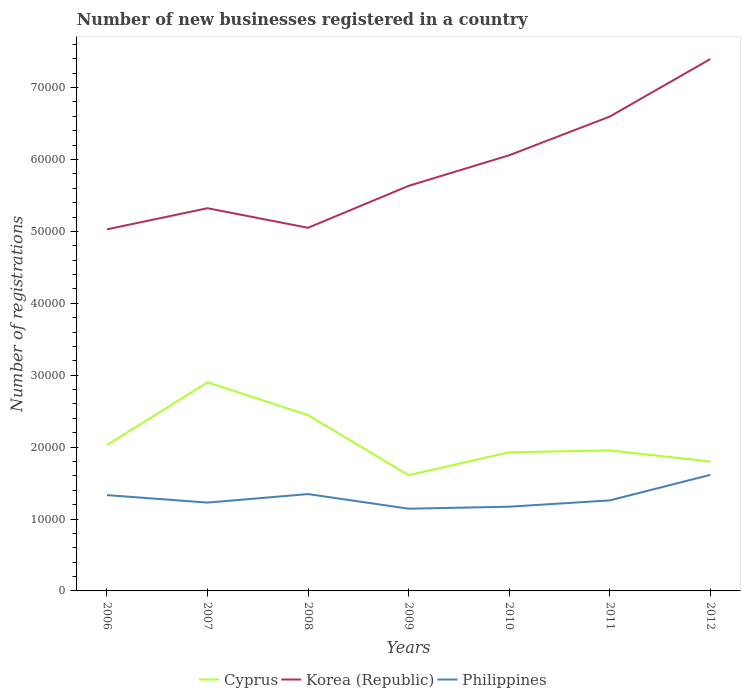Does the line corresponding to Philippines intersect with the line corresponding to Cyprus?
Keep it short and to the point. No. Is the number of lines equal to the number of legend labels?
Your answer should be compact. Yes. Across all years, what is the maximum number of new businesses registered in Korea (Republic)?
Your answer should be very brief. 5.03e+04. What is the total number of new businesses registered in Korea (Republic) in the graph?
Offer a terse response. -2.35e+04. What is the difference between the highest and the second highest number of new businesses registered in Korea (Republic)?
Offer a terse response. 2.37e+04. Is the number of new businesses registered in Korea (Republic) strictly greater than the number of new businesses registered in Cyprus over the years?
Provide a short and direct response. No. How many lines are there?
Offer a terse response. 3. How many legend labels are there?
Provide a succinct answer. 3. What is the title of the graph?
Your response must be concise. Number of new businesses registered in a country. Does "Gabon" appear as one of the legend labels in the graph?
Your answer should be very brief. No. What is the label or title of the X-axis?
Keep it short and to the point. Years. What is the label or title of the Y-axis?
Your response must be concise. Number of registrations. What is the Number of registrations in Cyprus in 2006?
Keep it short and to the point. 2.03e+04. What is the Number of registrations in Korea (Republic) in 2006?
Provide a succinct answer. 5.03e+04. What is the Number of registrations of Philippines in 2006?
Offer a very short reply. 1.33e+04. What is the Number of registrations in Cyprus in 2007?
Your answer should be very brief. 2.90e+04. What is the Number of registrations in Korea (Republic) in 2007?
Your answer should be very brief. 5.32e+04. What is the Number of registrations of Philippines in 2007?
Make the answer very short. 1.23e+04. What is the Number of registrations in Cyprus in 2008?
Provide a succinct answer. 2.45e+04. What is the Number of registrations in Korea (Republic) in 2008?
Your answer should be very brief. 5.05e+04. What is the Number of registrations of Philippines in 2008?
Keep it short and to the point. 1.35e+04. What is the Number of registrations of Cyprus in 2009?
Make the answer very short. 1.61e+04. What is the Number of registrations of Korea (Republic) in 2009?
Your answer should be compact. 5.63e+04. What is the Number of registrations of Philippines in 2009?
Your answer should be very brief. 1.14e+04. What is the Number of registrations of Cyprus in 2010?
Provide a succinct answer. 1.93e+04. What is the Number of registrations in Korea (Republic) in 2010?
Make the answer very short. 6.06e+04. What is the Number of registrations of Philippines in 2010?
Your answer should be very brief. 1.17e+04. What is the Number of registrations of Cyprus in 2011?
Make the answer very short. 1.95e+04. What is the Number of registrations in Korea (Republic) in 2011?
Your answer should be compact. 6.60e+04. What is the Number of registrations in Philippines in 2011?
Your answer should be compact. 1.26e+04. What is the Number of registrations of Cyprus in 2012?
Ensure brevity in your answer.  1.80e+04. What is the Number of registrations in Korea (Republic) in 2012?
Offer a very short reply. 7.40e+04. What is the Number of registrations in Philippines in 2012?
Your answer should be compact. 1.61e+04. Across all years, what is the maximum Number of registrations of Cyprus?
Give a very brief answer. 2.90e+04. Across all years, what is the maximum Number of registrations of Korea (Republic)?
Your answer should be very brief. 7.40e+04. Across all years, what is the maximum Number of registrations of Philippines?
Offer a terse response. 1.61e+04. Across all years, what is the minimum Number of registrations in Cyprus?
Provide a short and direct response. 1.61e+04. Across all years, what is the minimum Number of registrations in Korea (Republic)?
Your response must be concise. 5.03e+04. Across all years, what is the minimum Number of registrations in Philippines?
Your answer should be very brief. 1.14e+04. What is the total Number of registrations in Cyprus in the graph?
Provide a short and direct response. 1.47e+05. What is the total Number of registrations of Korea (Republic) in the graph?
Your answer should be compact. 4.11e+05. What is the total Number of registrations of Philippines in the graph?
Provide a succinct answer. 9.10e+04. What is the difference between the Number of registrations of Cyprus in 2006 and that in 2007?
Provide a short and direct response. -8736. What is the difference between the Number of registrations of Korea (Republic) in 2006 and that in 2007?
Provide a succinct answer. -2938. What is the difference between the Number of registrations in Philippines in 2006 and that in 2007?
Offer a very short reply. 1040. What is the difference between the Number of registrations in Cyprus in 2006 and that in 2008?
Offer a very short reply. -4173. What is the difference between the Number of registrations of Korea (Republic) in 2006 and that in 2008?
Your response must be concise. -216. What is the difference between the Number of registrations in Philippines in 2006 and that in 2008?
Your response must be concise. -145. What is the difference between the Number of registrations in Cyprus in 2006 and that in 2009?
Offer a very short reply. 4179. What is the difference between the Number of registrations of Korea (Republic) in 2006 and that in 2009?
Offer a very short reply. -6048. What is the difference between the Number of registrations of Philippines in 2006 and that in 2009?
Ensure brevity in your answer.  1890. What is the difference between the Number of registrations of Cyprus in 2006 and that in 2010?
Your answer should be compact. 1002. What is the difference between the Number of registrations of Korea (Republic) in 2006 and that in 2010?
Offer a terse response. -1.03e+04. What is the difference between the Number of registrations in Philippines in 2006 and that in 2010?
Provide a succinct answer. 1611. What is the difference between the Number of registrations in Cyprus in 2006 and that in 2011?
Provide a succinct answer. 742. What is the difference between the Number of registrations in Korea (Republic) in 2006 and that in 2011?
Your answer should be compact. -1.57e+04. What is the difference between the Number of registrations in Philippines in 2006 and that in 2011?
Your answer should be compact. 735. What is the difference between the Number of registrations of Cyprus in 2006 and that in 2012?
Offer a very short reply. 2281. What is the difference between the Number of registrations of Korea (Republic) in 2006 and that in 2012?
Your answer should be compact. -2.37e+04. What is the difference between the Number of registrations of Philippines in 2006 and that in 2012?
Your answer should be very brief. -2818. What is the difference between the Number of registrations of Cyprus in 2007 and that in 2008?
Offer a terse response. 4563. What is the difference between the Number of registrations in Korea (Republic) in 2007 and that in 2008?
Provide a short and direct response. 2722. What is the difference between the Number of registrations of Philippines in 2007 and that in 2008?
Your answer should be very brief. -1185. What is the difference between the Number of registrations of Cyprus in 2007 and that in 2009?
Provide a short and direct response. 1.29e+04. What is the difference between the Number of registrations of Korea (Republic) in 2007 and that in 2009?
Offer a very short reply. -3110. What is the difference between the Number of registrations of Philippines in 2007 and that in 2009?
Offer a very short reply. 850. What is the difference between the Number of registrations of Cyprus in 2007 and that in 2010?
Give a very brief answer. 9738. What is the difference between the Number of registrations in Korea (Republic) in 2007 and that in 2010?
Your answer should be very brief. -7366. What is the difference between the Number of registrations of Philippines in 2007 and that in 2010?
Provide a succinct answer. 571. What is the difference between the Number of registrations in Cyprus in 2007 and that in 2011?
Make the answer very short. 9478. What is the difference between the Number of registrations in Korea (Republic) in 2007 and that in 2011?
Your answer should be compact. -1.27e+04. What is the difference between the Number of registrations in Philippines in 2007 and that in 2011?
Offer a very short reply. -305. What is the difference between the Number of registrations in Cyprus in 2007 and that in 2012?
Your answer should be compact. 1.10e+04. What is the difference between the Number of registrations in Korea (Republic) in 2007 and that in 2012?
Your response must be concise. -2.07e+04. What is the difference between the Number of registrations of Philippines in 2007 and that in 2012?
Your answer should be very brief. -3858. What is the difference between the Number of registrations in Cyprus in 2008 and that in 2009?
Keep it short and to the point. 8352. What is the difference between the Number of registrations in Korea (Republic) in 2008 and that in 2009?
Keep it short and to the point. -5832. What is the difference between the Number of registrations of Philippines in 2008 and that in 2009?
Give a very brief answer. 2035. What is the difference between the Number of registrations in Cyprus in 2008 and that in 2010?
Your answer should be compact. 5175. What is the difference between the Number of registrations in Korea (Republic) in 2008 and that in 2010?
Provide a succinct answer. -1.01e+04. What is the difference between the Number of registrations of Philippines in 2008 and that in 2010?
Keep it short and to the point. 1756. What is the difference between the Number of registrations of Cyprus in 2008 and that in 2011?
Give a very brief answer. 4915. What is the difference between the Number of registrations in Korea (Republic) in 2008 and that in 2011?
Keep it short and to the point. -1.55e+04. What is the difference between the Number of registrations in Philippines in 2008 and that in 2011?
Offer a terse response. 880. What is the difference between the Number of registrations in Cyprus in 2008 and that in 2012?
Offer a very short reply. 6454. What is the difference between the Number of registrations of Korea (Republic) in 2008 and that in 2012?
Offer a terse response. -2.35e+04. What is the difference between the Number of registrations in Philippines in 2008 and that in 2012?
Keep it short and to the point. -2673. What is the difference between the Number of registrations of Cyprus in 2009 and that in 2010?
Offer a very short reply. -3177. What is the difference between the Number of registrations of Korea (Republic) in 2009 and that in 2010?
Give a very brief answer. -4256. What is the difference between the Number of registrations of Philippines in 2009 and that in 2010?
Your response must be concise. -279. What is the difference between the Number of registrations of Cyprus in 2009 and that in 2011?
Ensure brevity in your answer.  -3437. What is the difference between the Number of registrations of Korea (Republic) in 2009 and that in 2011?
Give a very brief answer. -9636. What is the difference between the Number of registrations in Philippines in 2009 and that in 2011?
Provide a short and direct response. -1155. What is the difference between the Number of registrations in Cyprus in 2009 and that in 2012?
Offer a terse response. -1898. What is the difference between the Number of registrations of Korea (Republic) in 2009 and that in 2012?
Ensure brevity in your answer.  -1.76e+04. What is the difference between the Number of registrations of Philippines in 2009 and that in 2012?
Ensure brevity in your answer.  -4708. What is the difference between the Number of registrations of Cyprus in 2010 and that in 2011?
Give a very brief answer. -260. What is the difference between the Number of registrations of Korea (Republic) in 2010 and that in 2011?
Offer a very short reply. -5380. What is the difference between the Number of registrations in Philippines in 2010 and that in 2011?
Your response must be concise. -876. What is the difference between the Number of registrations of Cyprus in 2010 and that in 2012?
Make the answer very short. 1279. What is the difference between the Number of registrations of Korea (Republic) in 2010 and that in 2012?
Your response must be concise. -1.34e+04. What is the difference between the Number of registrations of Philippines in 2010 and that in 2012?
Provide a succinct answer. -4429. What is the difference between the Number of registrations of Cyprus in 2011 and that in 2012?
Your response must be concise. 1539. What is the difference between the Number of registrations in Korea (Republic) in 2011 and that in 2012?
Make the answer very short. -7999. What is the difference between the Number of registrations of Philippines in 2011 and that in 2012?
Provide a succinct answer. -3553. What is the difference between the Number of registrations of Cyprus in 2006 and the Number of registrations of Korea (Republic) in 2007?
Your answer should be very brief. -3.29e+04. What is the difference between the Number of registrations in Cyprus in 2006 and the Number of registrations in Philippines in 2007?
Provide a succinct answer. 7995. What is the difference between the Number of registrations in Korea (Republic) in 2006 and the Number of registrations in Philippines in 2007?
Your response must be concise. 3.80e+04. What is the difference between the Number of registrations in Cyprus in 2006 and the Number of registrations in Korea (Republic) in 2008?
Provide a succinct answer. -3.02e+04. What is the difference between the Number of registrations of Cyprus in 2006 and the Number of registrations of Philippines in 2008?
Your answer should be compact. 6810. What is the difference between the Number of registrations of Korea (Republic) in 2006 and the Number of registrations of Philippines in 2008?
Make the answer very short. 3.68e+04. What is the difference between the Number of registrations of Cyprus in 2006 and the Number of registrations of Korea (Republic) in 2009?
Offer a very short reply. -3.61e+04. What is the difference between the Number of registrations of Cyprus in 2006 and the Number of registrations of Philippines in 2009?
Make the answer very short. 8845. What is the difference between the Number of registrations of Korea (Republic) in 2006 and the Number of registrations of Philippines in 2009?
Make the answer very short. 3.89e+04. What is the difference between the Number of registrations in Cyprus in 2006 and the Number of registrations in Korea (Republic) in 2010?
Provide a succinct answer. -4.03e+04. What is the difference between the Number of registrations of Cyprus in 2006 and the Number of registrations of Philippines in 2010?
Your answer should be compact. 8566. What is the difference between the Number of registrations in Korea (Republic) in 2006 and the Number of registrations in Philippines in 2010?
Make the answer very short. 3.86e+04. What is the difference between the Number of registrations in Cyprus in 2006 and the Number of registrations in Korea (Republic) in 2011?
Give a very brief answer. -4.57e+04. What is the difference between the Number of registrations of Cyprus in 2006 and the Number of registrations of Philippines in 2011?
Keep it short and to the point. 7690. What is the difference between the Number of registrations of Korea (Republic) in 2006 and the Number of registrations of Philippines in 2011?
Provide a succinct answer. 3.77e+04. What is the difference between the Number of registrations of Cyprus in 2006 and the Number of registrations of Korea (Republic) in 2012?
Your response must be concise. -5.37e+04. What is the difference between the Number of registrations of Cyprus in 2006 and the Number of registrations of Philippines in 2012?
Ensure brevity in your answer.  4137. What is the difference between the Number of registrations in Korea (Republic) in 2006 and the Number of registrations in Philippines in 2012?
Keep it short and to the point. 3.41e+04. What is the difference between the Number of registrations in Cyprus in 2007 and the Number of registrations in Korea (Republic) in 2008?
Provide a short and direct response. -2.15e+04. What is the difference between the Number of registrations in Cyprus in 2007 and the Number of registrations in Philippines in 2008?
Offer a terse response. 1.55e+04. What is the difference between the Number of registrations in Korea (Republic) in 2007 and the Number of registrations in Philippines in 2008?
Your answer should be very brief. 3.98e+04. What is the difference between the Number of registrations of Cyprus in 2007 and the Number of registrations of Korea (Republic) in 2009?
Give a very brief answer. -2.73e+04. What is the difference between the Number of registrations of Cyprus in 2007 and the Number of registrations of Philippines in 2009?
Make the answer very short. 1.76e+04. What is the difference between the Number of registrations in Korea (Republic) in 2007 and the Number of registrations in Philippines in 2009?
Offer a very short reply. 4.18e+04. What is the difference between the Number of registrations of Cyprus in 2007 and the Number of registrations of Korea (Republic) in 2010?
Your response must be concise. -3.16e+04. What is the difference between the Number of registrations in Cyprus in 2007 and the Number of registrations in Philippines in 2010?
Offer a terse response. 1.73e+04. What is the difference between the Number of registrations in Korea (Republic) in 2007 and the Number of registrations in Philippines in 2010?
Offer a terse response. 4.15e+04. What is the difference between the Number of registrations of Cyprus in 2007 and the Number of registrations of Korea (Republic) in 2011?
Give a very brief answer. -3.70e+04. What is the difference between the Number of registrations in Cyprus in 2007 and the Number of registrations in Philippines in 2011?
Provide a succinct answer. 1.64e+04. What is the difference between the Number of registrations in Korea (Republic) in 2007 and the Number of registrations in Philippines in 2011?
Provide a short and direct response. 4.06e+04. What is the difference between the Number of registrations in Cyprus in 2007 and the Number of registrations in Korea (Republic) in 2012?
Provide a short and direct response. -4.50e+04. What is the difference between the Number of registrations of Cyprus in 2007 and the Number of registrations of Philippines in 2012?
Offer a very short reply. 1.29e+04. What is the difference between the Number of registrations of Korea (Republic) in 2007 and the Number of registrations of Philippines in 2012?
Ensure brevity in your answer.  3.71e+04. What is the difference between the Number of registrations in Cyprus in 2008 and the Number of registrations in Korea (Republic) in 2009?
Provide a short and direct response. -3.19e+04. What is the difference between the Number of registrations of Cyprus in 2008 and the Number of registrations of Philippines in 2009?
Make the answer very short. 1.30e+04. What is the difference between the Number of registrations in Korea (Republic) in 2008 and the Number of registrations in Philippines in 2009?
Your response must be concise. 3.91e+04. What is the difference between the Number of registrations in Cyprus in 2008 and the Number of registrations in Korea (Republic) in 2010?
Give a very brief answer. -3.61e+04. What is the difference between the Number of registrations in Cyprus in 2008 and the Number of registrations in Philippines in 2010?
Provide a short and direct response. 1.27e+04. What is the difference between the Number of registrations of Korea (Republic) in 2008 and the Number of registrations of Philippines in 2010?
Your answer should be compact. 3.88e+04. What is the difference between the Number of registrations of Cyprus in 2008 and the Number of registrations of Korea (Republic) in 2011?
Offer a terse response. -4.15e+04. What is the difference between the Number of registrations of Cyprus in 2008 and the Number of registrations of Philippines in 2011?
Your response must be concise. 1.19e+04. What is the difference between the Number of registrations of Korea (Republic) in 2008 and the Number of registrations of Philippines in 2011?
Offer a very short reply. 3.79e+04. What is the difference between the Number of registrations of Cyprus in 2008 and the Number of registrations of Korea (Republic) in 2012?
Your answer should be compact. -4.95e+04. What is the difference between the Number of registrations of Cyprus in 2008 and the Number of registrations of Philippines in 2012?
Keep it short and to the point. 8310. What is the difference between the Number of registrations of Korea (Republic) in 2008 and the Number of registrations of Philippines in 2012?
Keep it short and to the point. 3.44e+04. What is the difference between the Number of registrations in Cyprus in 2009 and the Number of registrations in Korea (Republic) in 2010?
Offer a very short reply. -4.45e+04. What is the difference between the Number of registrations in Cyprus in 2009 and the Number of registrations in Philippines in 2010?
Provide a short and direct response. 4387. What is the difference between the Number of registrations of Korea (Republic) in 2009 and the Number of registrations of Philippines in 2010?
Offer a very short reply. 4.46e+04. What is the difference between the Number of registrations in Cyprus in 2009 and the Number of registrations in Korea (Republic) in 2011?
Offer a very short reply. -4.99e+04. What is the difference between the Number of registrations of Cyprus in 2009 and the Number of registrations of Philippines in 2011?
Provide a succinct answer. 3511. What is the difference between the Number of registrations of Korea (Republic) in 2009 and the Number of registrations of Philippines in 2011?
Your answer should be very brief. 4.37e+04. What is the difference between the Number of registrations in Cyprus in 2009 and the Number of registrations in Korea (Republic) in 2012?
Provide a succinct answer. -5.79e+04. What is the difference between the Number of registrations in Cyprus in 2009 and the Number of registrations in Philippines in 2012?
Give a very brief answer. -42. What is the difference between the Number of registrations in Korea (Republic) in 2009 and the Number of registrations in Philippines in 2012?
Offer a terse response. 4.02e+04. What is the difference between the Number of registrations in Cyprus in 2010 and the Number of registrations in Korea (Republic) in 2011?
Ensure brevity in your answer.  -4.67e+04. What is the difference between the Number of registrations of Cyprus in 2010 and the Number of registrations of Philippines in 2011?
Offer a very short reply. 6688. What is the difference between the Number of registrations of Korea (Republic) in 2010 and the Number of registrations of Philippines in 2011?
Provide a succinct answer. 4.80e+04. What is the difference between the Number of registrations of Cyprus in 2010 and the Number of registrations of Korea (Republic) in 2012?
Offer a terse response. -5.47e+04. What is the difference between the Number of registrations in Cyprus in 2010 and the Number of registrations in Philippines in 2012?
Give a very brief answer. 3135. What is the difference between the Number of registrations in Korea (Republic) in 2010 and the Number of registrations in Philippines in 2012?
Give a very brief answer. 4.44e+04. What is the difference between the Number of registrations of Cyprus in 2011 and the Number of registrations of Korea (Republic) in 2012?
Your answer should be very brief. -5.44e+04. What is the difference between the Number of registrations in Cyprus in 2011 and the Number of registrations in Philippines in 2012?
Make the answer very short. 3395. What is the difference between the Number of registrations of Korea (Republic) in 2011 and the Number of registrations of Philippines in 2012?
Offer a very short reply. 4.98e+04. What is the average Number of registrations in Cyprus per year?
Offer a terse response. 2.10e+04. What is the average Number of registrations in Korea (Republic) per year?
Make the answer very short. 5.87e+04. What is the average Number of registrations in Philippines per year?
Your answer should be compact. 1.30e+04. In the year 2006, what is the difference between the Number of registrations of Cyprus and Number of registrations of Korea (Republic)?
Your response must be concise. -3.00e+04. In the year 2006, what is the difference between the Number of registrations of Cyprus and Number of registrations of Philippines?
Offer a terse response. 6955. In the year 2006, what is the difference between the Number of registrations in Korea (Republic) and Number of registrations in Philippines?
Make the answer very short. 3.70e+04. In the year 2007, what is the difference between the Number of registrations in Cyprus and Number of registrations in Korea (Republic)?
Keep it short and to the point. -2.42e+04. In the year 2007, what is the difference between the Number of registrations in Cyprus and Number of registrations in Philippines?
Ensure brevity in your answer.  1.67e+04. In the year 2007, what is the difference between the Number of registrations of Korea (Republic) and Number of registrations of Philippines?
Provide a succinct answer. 4.09e+04. In the year 2008, what is the difference between the Number of registrations in Cyprus and Number of registrations in Korea (Republic)?
Your answer should be compact. -2.61e+04. In the year 2008, what is the difference between the Number of registrations in Cyprus and Number of registrations in Philippines?
Your answer should be very brief. 1.10e+04. In the year 2008, what is the difference between the Number of registrations in Korea (Republic) and Number of registrations in Philippines?
Provide a succinct answer. 3.70e+04. In the year 2009, what is the difference between the Number of registrations in Cyprus and Number of registrations in Korea (Republic)?
Your answer should be compact. -4.02e+04. In the year 2009, what is the difference between the Number of registrations in Cyprus and Number of registrations in Philippines?
Offer a very short reply. 4666. In the year 2009, what is the difference between the Number of registrations of Korea (Republic) and Number of registrations of Philippines?
Provide a short and direct response. 4.49e+04. In the year 2010, what is the difference between the Number of registrations in Cyprus and Number of registrations in Korea (Republic)?
Your answer should be very brief. -4.13e+04. In the year 2010, what is the difference between the Number of registrations in Cyprus and Number of registrations in Philippines?
Give a very brief answer. 7564. In the year 2010, what is the difference between the Number of registrations in Korea (Republic) and Number of registrations in Philippines?
Offer a very short reply. 4.89e+04. In the year 2011, what is the difference between the Number of registrations of Cyprus and Number of registrations of Korea (Republic)?
Your answer should be very brief. -4.64e+04. In the year 2011, what is the difference between the Number of registrations of Cyprus and Number of registrations of Philippines?
Your answer should be very brief. 6948. In the year 2011, what is the difference between the Number of registrations in Korea (Republic) and Number of registrations in Philippines?
Offer a terse response. 5.34e+04. In the year 2012, what is the difference between the Number of registrations of Cyprus and Number of registrations of Korea (Republic)?
Offer a very short reply. -5.60e+04. In the year 2012, what is the difference between the Number of registrations in Cyprus and Number of registrations in Philippines?
Your answer should be compact. 1856. In the year 2012, what is the difference between the Number of registrations of Korea (Republic) and Number of registrations of Philippines?
Give a very brief answer. 5.78e+04. What is the ratio of the Number of registrations of Cyprus in 2006 to that in 2007?
Give a very brief answer. 0.7. What is the ratio of the Number of registrations in Korea (Republic) in 2006 to that in 2007?
Ensure brevity in your answer.  0.94. What is the ratio of the Number of registrations in Philippines in 2006 to that in 2007?
Your response must be concise. 1.08. What is the ratio of the Number of registrations in Cyprus in 2006 to that in 2008?
Offer a very short reply. 0.83. What is the ratio of the Number of registrations of Philippines in 2006 to that in 2008?
Keep it short and to the point. 0.99. What is the ratio of the Number of registrations in Cyprus in 2006 to that in 2009?
Your response must be concise. 1.26. What is the ratio of the Number of registrations in Korea (Republic) in 2006 to that in 2009?
Give a very brief answer. 0.89. What is the ratio of the Number of registrations in Philippines in 2006 to that in 2009?
Provide a succinct answer. 1.17. What is the ratio of the Number of registrations in Cyprus in 2006 to that in 2010?
Your answer should be compact. 1.05. What is the ratio of the Number of registrations in Korea (Republic) in 2006 to that in 2010?
Offer a very short reply. 0.83. What is the ratio of the Number of registrations in Philippines in 2006 to that in 2010?
Make the answer very short. 1.14. What is the ratio of the Number of registrations of Cyprus in 2006 to that in 2011?
Ensure brevity in your answer.  1.04. What is the ratio of the Number of registrations of Korea (Republic) in 2006 to that in 2011?
Provide a short and direct response. 0.76. What is the ratio of the Number of registrations in Philippines in 2006 to that in 2011?
Your answer should be very brief. 1.06. What is the ratio of the Number of registrations in Cyprus in 2006 to that in 2012?
Your response must be concise. 1.13. What is the ratio of the Number of registrations of Korea (Republic) in 2006 to that in 2012?
Your answer should be compact. 0.68. What is the ratio of the Number of registrations of Philippines in 2006 to that in 2012?
Your answer should be very brief. 0.83. What is the ratio of the Number of registrations in Cyprus in 2007 to that in 2008?
Give a very brief answer. 1.19. What is the ratio of the Number of registrations of Korea (Republic) in 2007 to that in 2008?
Keep it short and to the point. 1.05. What is the ratio of the Number of registrations in Philippines in 2007 to that in 2008?
Your response must be concise. 0.91. What is the ratio of the Number of registrations of Cyprus in 2007 to that in 2009?
Your response must be concise. 1.8. What is the ratio of the Number of registrations of Korea (Republic) in 2007 to that in 2009?
Keep it short and to the point. 0.94. What is the ratio of the Number of registrations of Philippines in 2007 to that in 2009?
Your answer should be compact. 1.07. What is the ratio of the Number of registrations in Cyprus in 2007 to that in 2010?
Provide a short and direct response. 1.51. What is the ratio of the Number of registrations of Korea (Republic) in 2007 to that in 2010?
Your answer should be compact. 0.88. What is the ratio of the Number of registrations of Philippines in 2007 to that in 2010?
Offer a terse response. 1.05. What is the ratio of the Number of registrations in Cyprus in 2007 to that in 2011?
Offer a very short reply. 1.49. What is the ratio of the Number of registrations in Korea (Republic) in 2007 to that in 2011?
Keep it short and to the point. 0.81. What is the ratio of the Number of registrations in Philippines in 2007 to that in 2011?
Offer a very short reply. 0.98. What is the ratio of the Number of registrations of Cyprus in 2007 to that in 2012?
Keep it short and to the point. 1.61. What is the ratio of the Number of registrations of Korea (Republic) in 2007 to that in 2012?
Your answer should be compact. 0.72. What is the ratio of the Number of registrations of Philippines in 2007 to that in 2012?
Give a very brief answer. 0.76. What is the ratio of the Number of registrations of Cyprus in 2008 to that in 2009?
Give a very brief answer. 1.52. What is the ratio of the Number of registrations of Korea (Republic) in 2008 to that in 2009?
Your response must be concise. 0.9. What is the ratio of the Number of registrations in Philippines in 2008 to that in 2009?
Provide a succinct answer. 1.18. What is the ratio of the Number of registrations of Cyprus in 2008 to that in 2010?
Give a very brief answer. 1.27. What is the ratio of the Number of registrations in Korea (Republic) in 2008 to that in 2010?
Provide a succinct answer. 0.83. What is the ratio of the Number of registrations in Philippines in 2008 to that in 2010?
Ensure brevity in your answer.  1.15. What is the ratio of the Number of registrations of Cyprus in 2008 to that in 2011?
Your answer should be very brief. 1.25. What is the ratio of the Number of registrations in Korea (Republic) in 2008 to that in 2011?
Give a very brief answer. 0.77. What is the ratio of the Number of registrations of Philippines in 2008 to that in 2011?
Offer a very short reply. 1.07. What is the ratio of the Number of registrations of Cyprus in 2008 to that in 2012?
Keep it short and to the point. 1.36. What is the ratio of the Number of registrations in Korea (Republic) in 2008 to that in 2012?
Keep it short and to the point. 0.68. What is the ratio of the Number of registrations in Philippines in 2008 to that in 2012?
Provide a short and direct response. 0.83. What is the ratio of the Number of registrations of Cyprus in 2009 to that in 2010?
Offer a terse response. 0.84. What is the ratio of the Number of registrations of Korea (Republic) in 2009 to that in 2010?
Keep it short and to the point. 0.93. What is the ratio of the Number of registrations of Philippines in 2009 to that in 2010?
Provide a succinct answer. 0.98. What is the ratio of the Number of registrations of Cyprus in 2009 to that in 2011?
Your response must be concise. 0.82. What is the ratio of the Number of registrations in Korea (Republic) in 2009 to that in 2011?
Provide a short and direct response. 0.85. What is the ratio of the Number of registrations of Philippines in 2009 to that in 2011?
Ensure brevity in your answer.  0.91. What is the ratio of the Number of registrations of Cyprus in 2009 to that in 2012?
Offer a terse response. 0.89. What is the ratio of the Number of registrations in Korea (Republic) in 2009 to that in 2012?
Your answer should be compact. 0.76. What is the ratio of the Number of registrations in Philippines in 2009 to that in 2012?
Offer a terse response. 0.71. What is the ratio of the Number of registrations of Cyprus in 2010 to that in 2011?
Your answer should be compact. 0.99. What is the ratio of the Number of registrations of Korea (Republic) in 2010 to that in 2011?
Offer a terse response. 0.92. What is the ratio of the Number of registrations in Philippines in 2010 to that in 2011?
Keep it short and to the point. 0.93. What is the ratio of the Number of registrations in Cyprus in 2010 to that in 2012?
Keep it short and to the point. 1.07. What is the ratio of the Number of registrations of Korea (Republic) in 2010 to that in 2012?
Offer a terse response. 0.82. What is the ratio of the Number of registrations in Philippines in 2010 to that in 2012?
Provide a short and direct response. 0.73. What is the ratio of the Number of registrations in Cyprus in 2011 to that in 2012?
Keep it short and to the point. 1.09. What is the ratio of the Number of registrations in Korea (Republic) in 2011 to that in 2012?
Provide a succinct answer. 0.89. What is the ratio of the Number of registrations of Philippines in 2011 to that in 2012?
Provide a short and direct response. 0.78. What is the difference between the highest and the second highest Number of registrations of Cyprus?
Your response must be concise. 4563. What is the difference between the highest and the second highest Number of registrations in Korea (Republic)?
Provide a short and direct response. 7999. What is the difference between the highest and the second highest Number of registrations in Philippines?
Give a very brief answer. 2673. What is the difference between the highest and the lowest Number of registrations of Cyprus?
Give a very brief answer. 1.29e+04. What is the difference between the highest and the lowest Number of registrations of Korea (Republic)?
Keep it short and to the point. 2.37e+04. What is the difference between the highest and the lowest Number of registrations of Philippines?
Provide a short and direct response. 4708. 